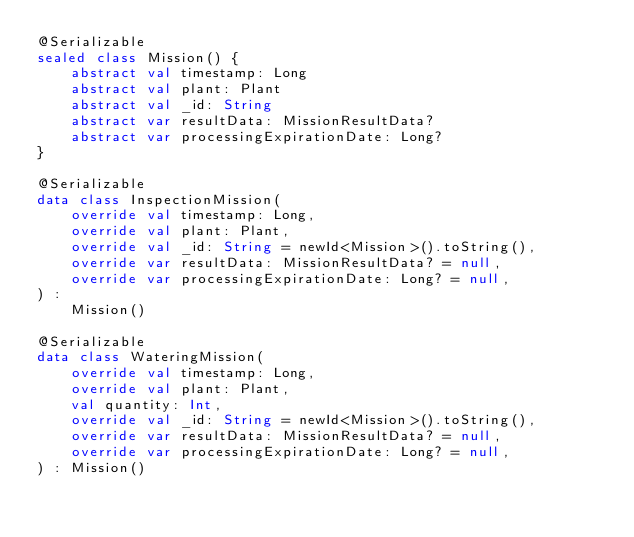<code> <loc_0><loc_0><loc_500><loc_500><_Kotlin_>@Serializable
sealed class Mission() {
    abstract val timestamp: Long
    abstract val plant: Plant
    abstract val _id: String
    abstract var resultData: MissionResultData?
    abstract var processingExpirationDate: Long?
}

@Serializable
data class InspectionMission(
    override val timestamp: Long,
    override val plant: Plant,
    override val _id: String = newId<Mission>().toString(),
    override var resultData: MissionResultData? = null,
    override var processingExpirationDate: Long? = null,
) :
    Mission()

@Serializable
data class WateringMission(
    override val timestamp: Long,
    override val plant: Plant,
    val quantity: Int,
    override val _id: String = newId<Mission>().toString(),
    override var resultData: MissionResultData? = null,
    override var processingExpirationDate: Long? = null,
) : Mission()</code> 